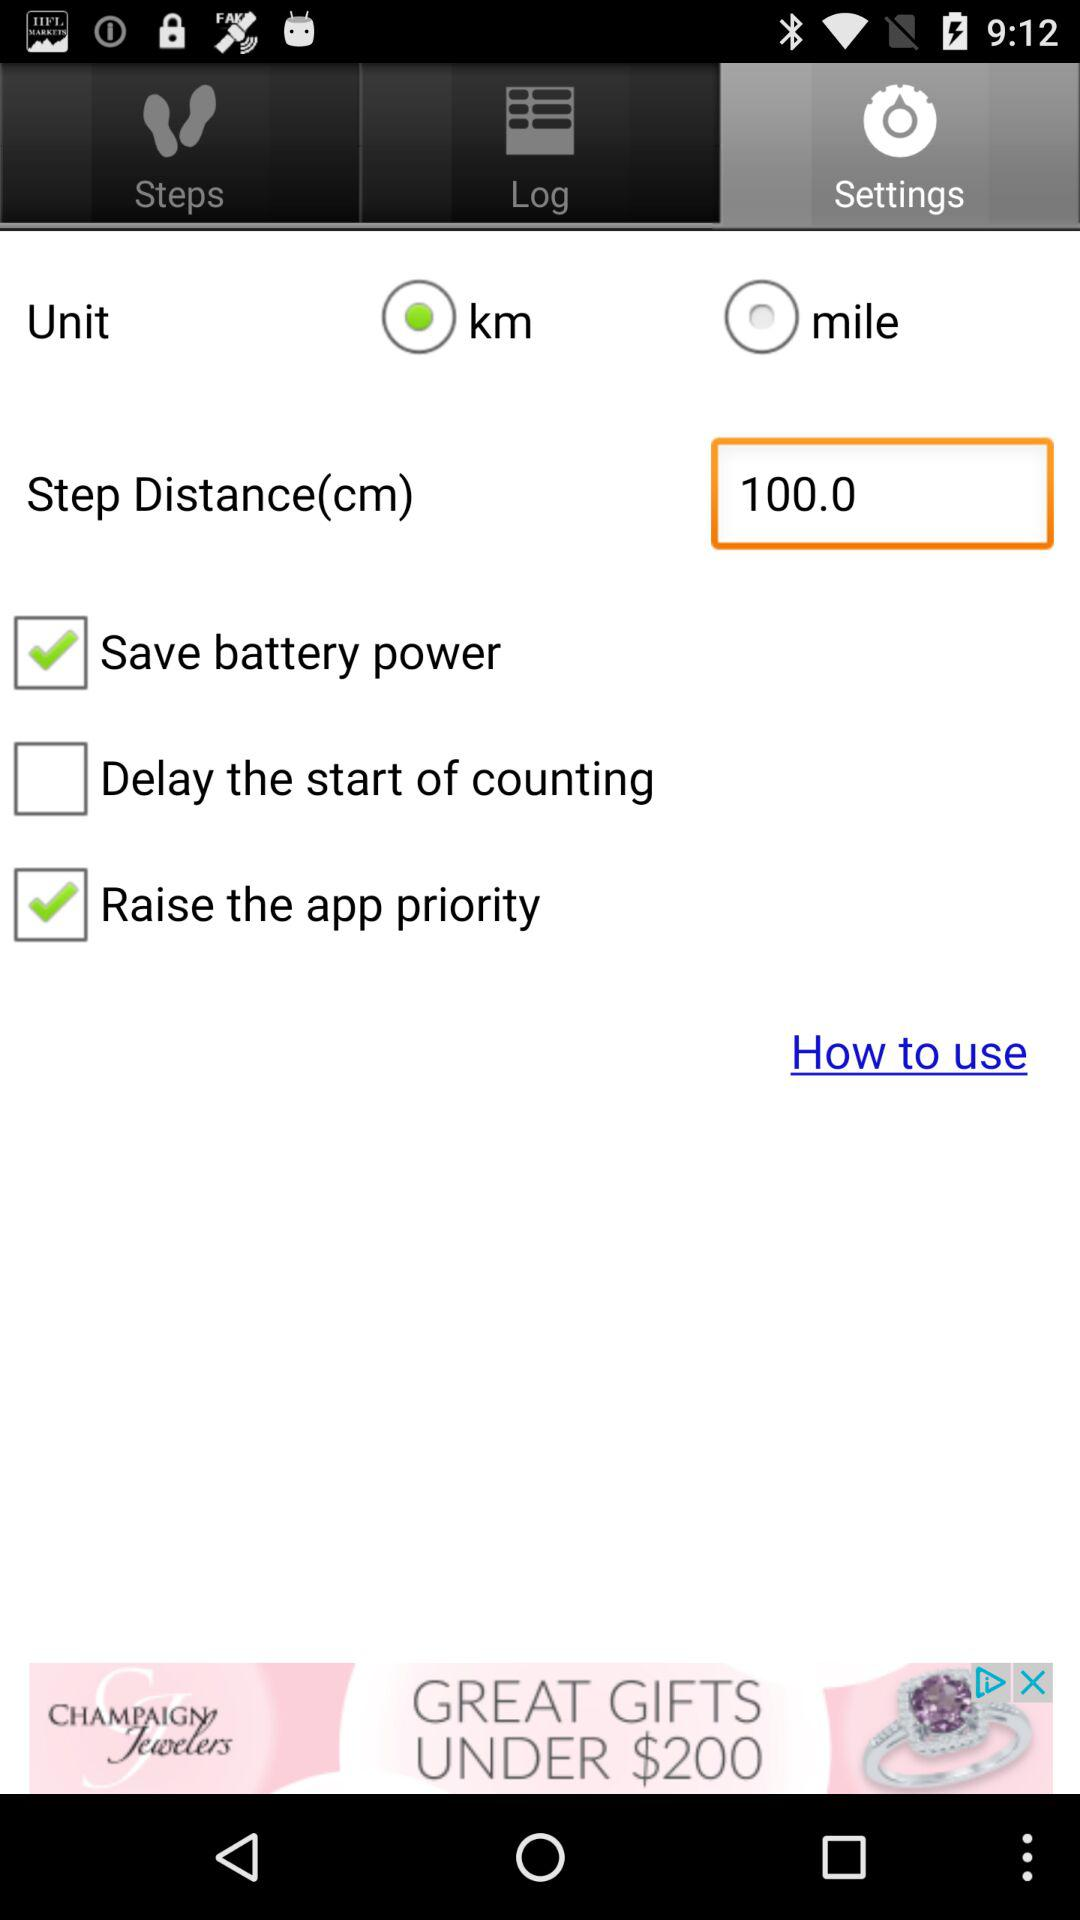How many options are there for selecting the unit of measurement?
Answer the question using a single word or phrase. 2 